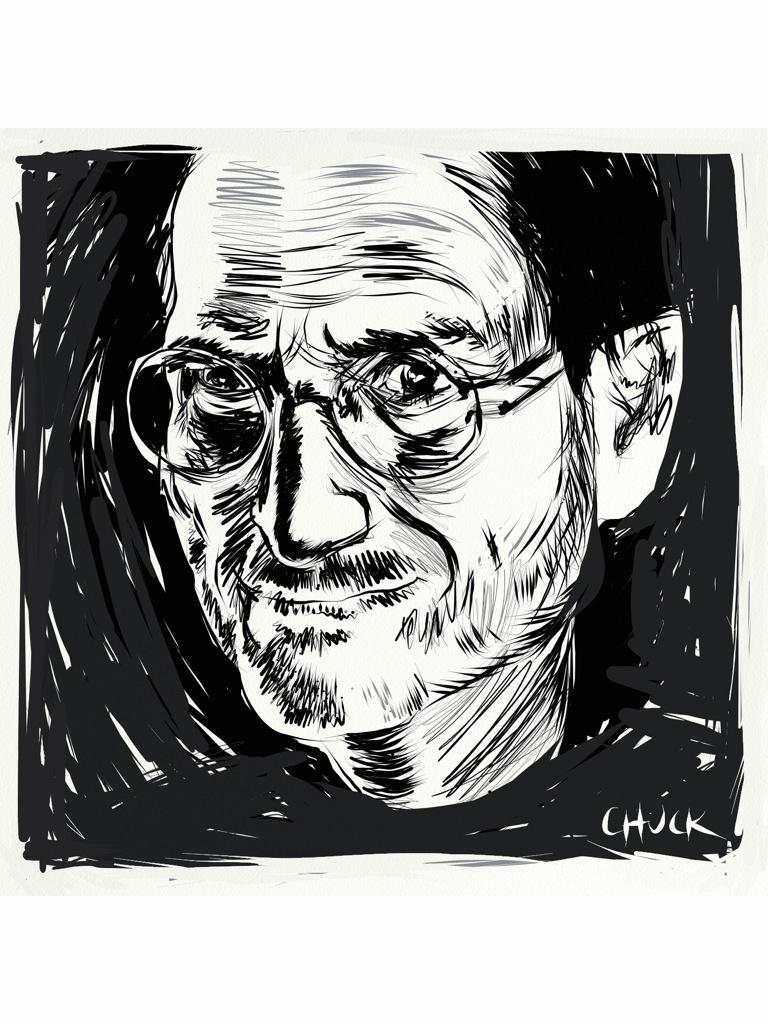What is the main subject of the image? There is a depiction of a man in the image. Is there any text present in the image? Yes, there is text written on the right bottom side of the image. What color scheme is used in the image? The image is black and white in color. What type of branch is the man holding in the image? There is no branch present in the image; it only depicts a man and text. What color are the man's trousers in the image? The image is black and white, so it is not possible to determine the color of the man's trousers. 